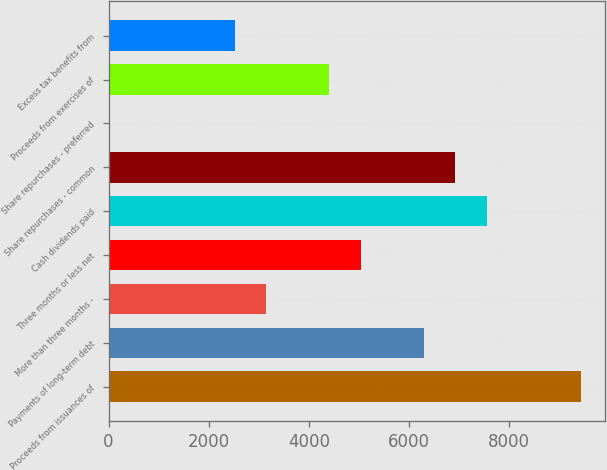Convert chart to OTSL. <chart><loc_0><loc_0><loc_500><loc_500><bar_chart><fcel>Proceeds from issuances of<fcel>Payments of long-term debt<fcel>More than three months -<fcel>Three months or less net<fcel>Cash dividends paid<fcel>Share repurchases - common<fcel>Share repurchases - preferred<fcel>Proceeds from exercises of<fcel>Excess tax benefits from<nl><fcel>9442<fcel>6297<fcel>3152<fcel>5039<fcel>7555<fcel>6926<fcel>7<fcel>4410<fcel>2523<nl></chart> 